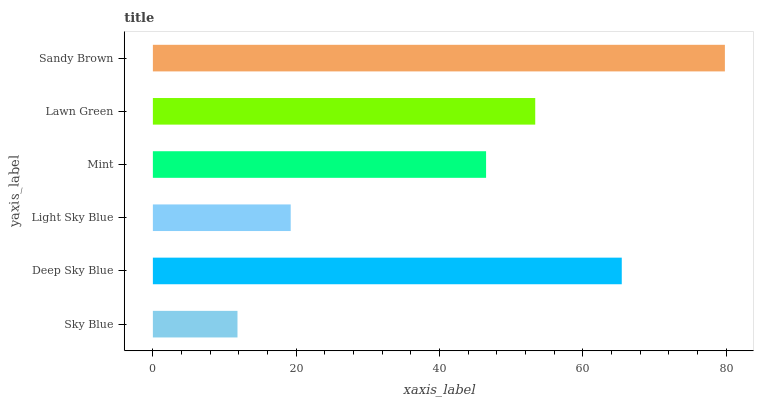Is Sky Blue the minimum?
Answer yes or no. Yes. Is Sandy Brown the maximum?
Answer yes or no. Yes. Is Deep Sky Blue the minimum?
Answer yes or no. No. Is Deep Sky Blue the maximum?
Answer yes or no. No. Is Deep Sky Blue greater than Sky Blue?
Answer yes or no. Yes. Is Sky Blue less than Deep Sky Blue?
Answer yes or no. Yes. Is Sky Blue greater than Deep Sky Blue?
Answer yes or no. No. Is Deep Sky Blue less than Sky Blue?
Answer yes or no. No. Is Lawn Green the high median?
Answer yes or no. Yes. Is Mint the low median?
Answer yes or no. Yes. Is Sandy Brown the high median?
Answer yes or no. No. Is Sky Blue the low median?
Answer yes or no. No. 